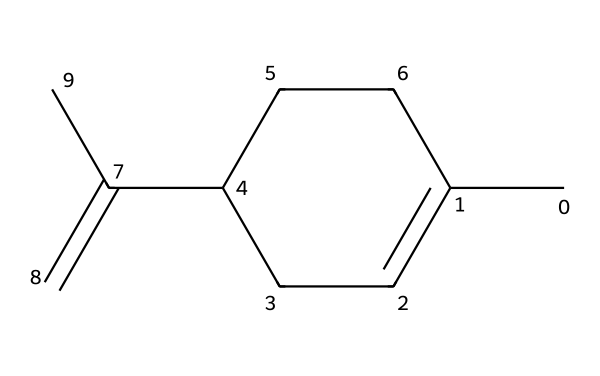What is the number of carbon atoms in limonene? In the SMILES representation, "CC1=CCC(CC1)C(=C)C," there are a total of 10 'C' characters, indicating there are 10 carbon atoms in limonene.
Answer: 10 How many double bonds are present in the structure? The notation "C(=C)" indicates a double bond, and since there is only one instance of this in the SMILES, there is one double bond present in the structure.
Answer: 1 What type of chemical is limonene classified as? Limonene is a cyclic terpene, which is indicated by its cyclic structure (noted by the presence of a ring 'C1...C1') and its general classification as a terpene in organic chemistry.
Answer: cyclic terpene How many hydrogen atoms are connected to each carbon in limonene? To determine the number of hydrogen atoms, we calculate based on the tetravalency of carbon. Given the double bond and the carbon ring structure, the average number of hydrogen atoms per carbon can be derived, showing a total of 16 hydrogen atoms connected to the carbons.
Answer: 16 Is limonene a saturated or unsaturated compound? The presence of a double bond (shown in "C(=C)") indicates that limonene is unsaturated, as saturated compounds would only have single bonds between the carbon atoms.
Answer: unsaturated What is the molecular formula for limonene? By counting the carbon (C) and hydrogen (H) atoms from the structure, the molecular formula can be deduced as C10H16, which encapsulates the atomic count from the chemical structure.
Answer: C10H16 What kind of ring structure does limonene have? Limonene has a cyclohexene-like ring structure due to the cyclic arrangement of carbon atoms and the presence of at least one double bond within the ring, which aligns with the properties of cycloalkenes.
Answer: cyclohexene-like 